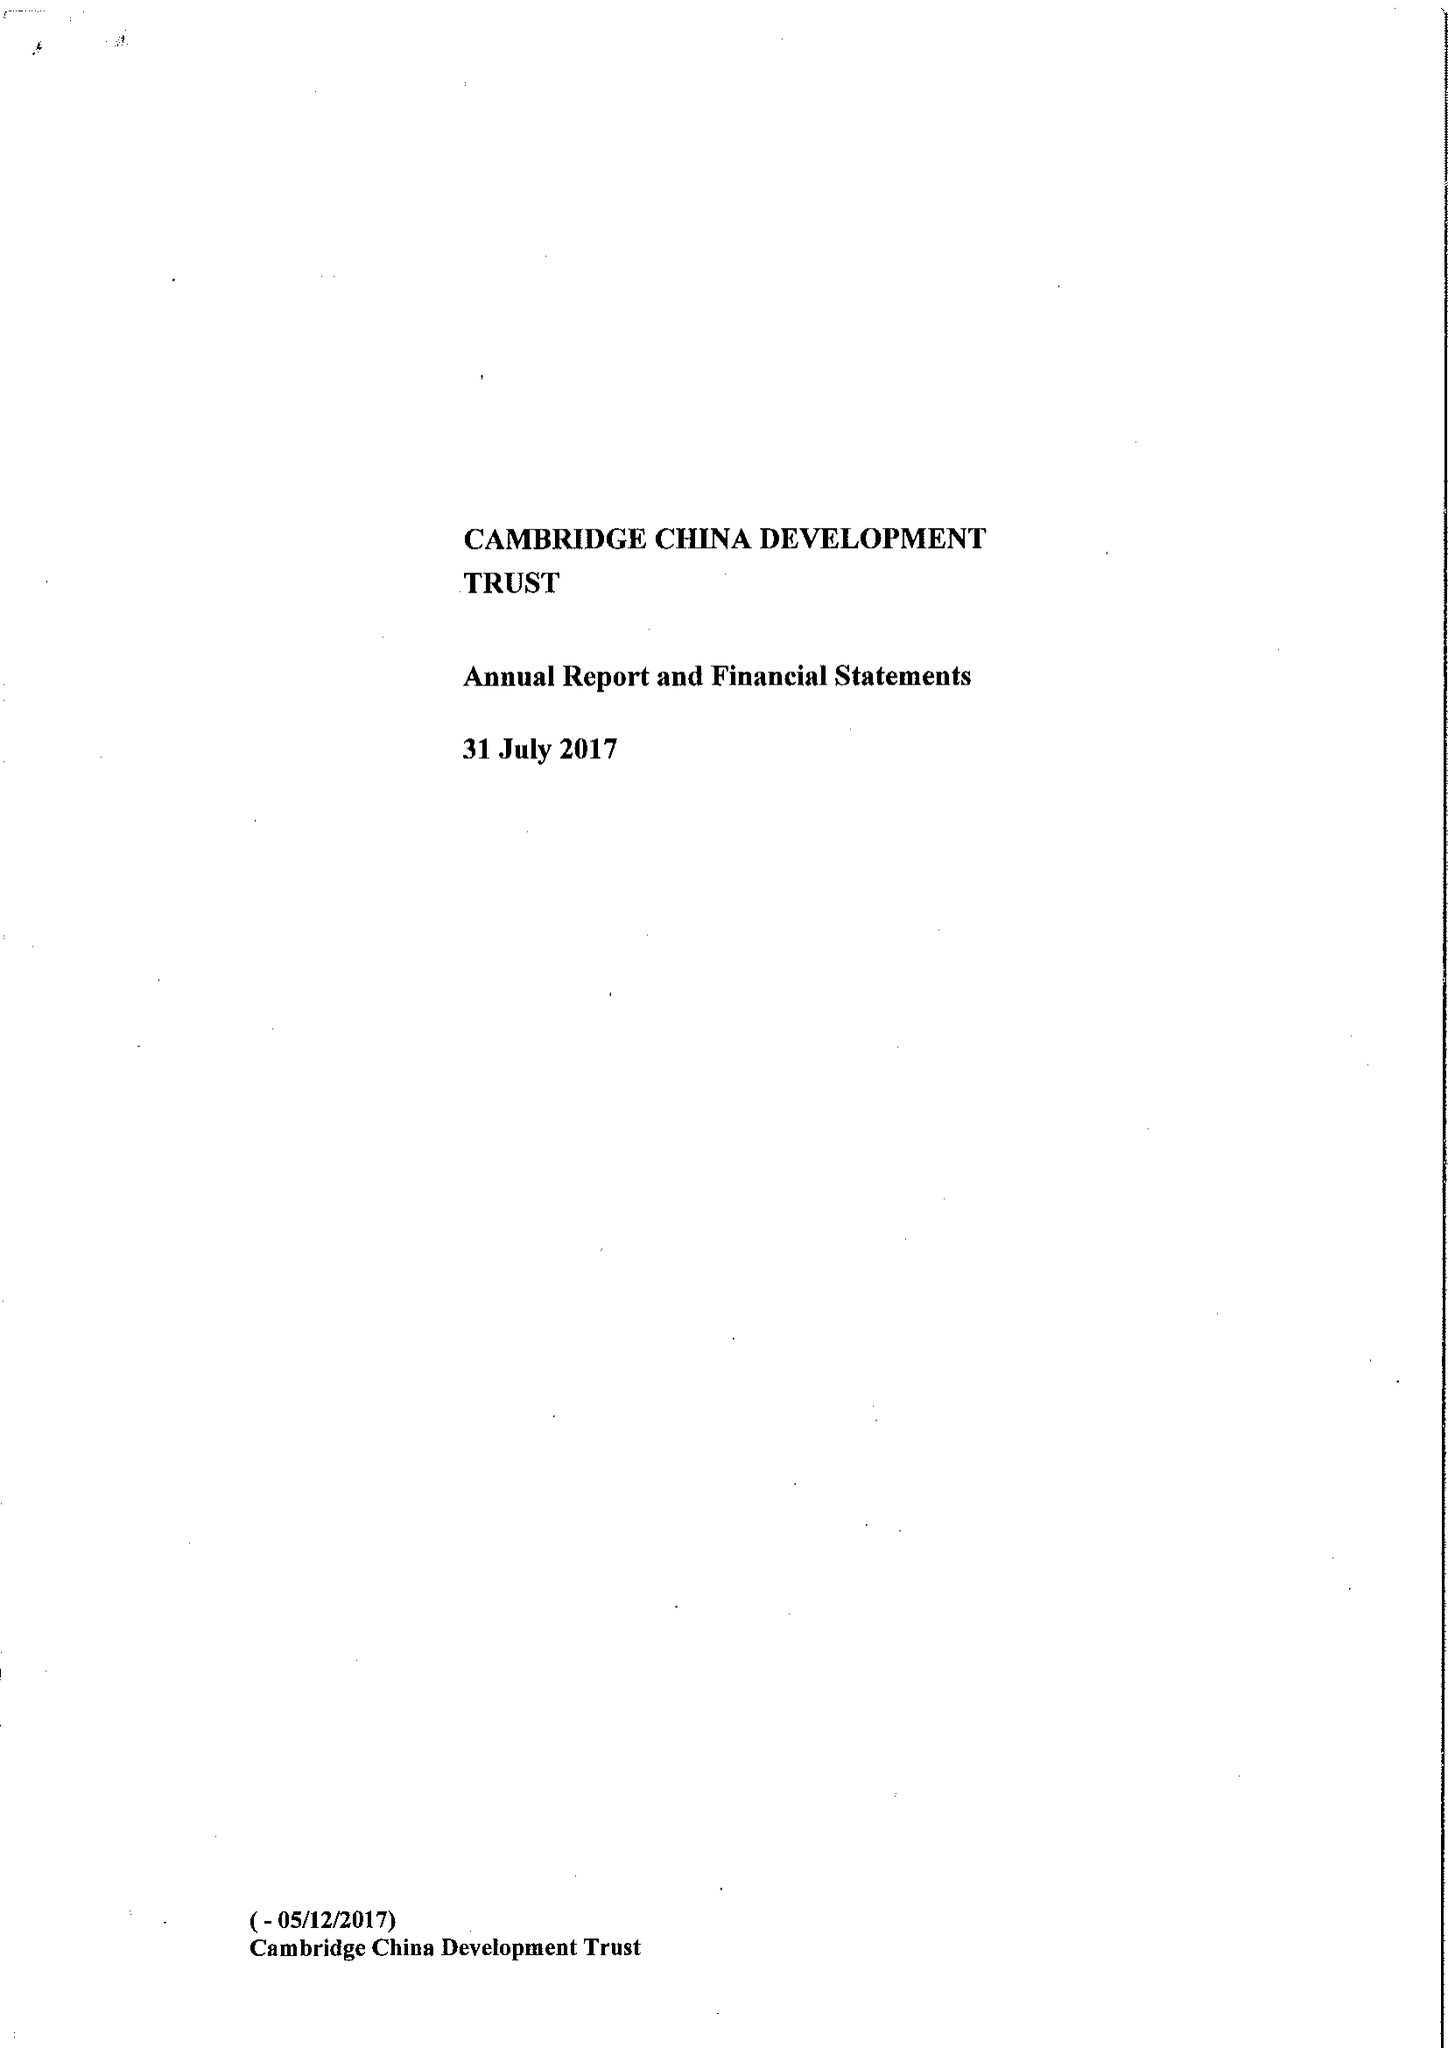What is the value for the address__post_town?
Answer the question using a single word or phrase. CAMBRIDGE 